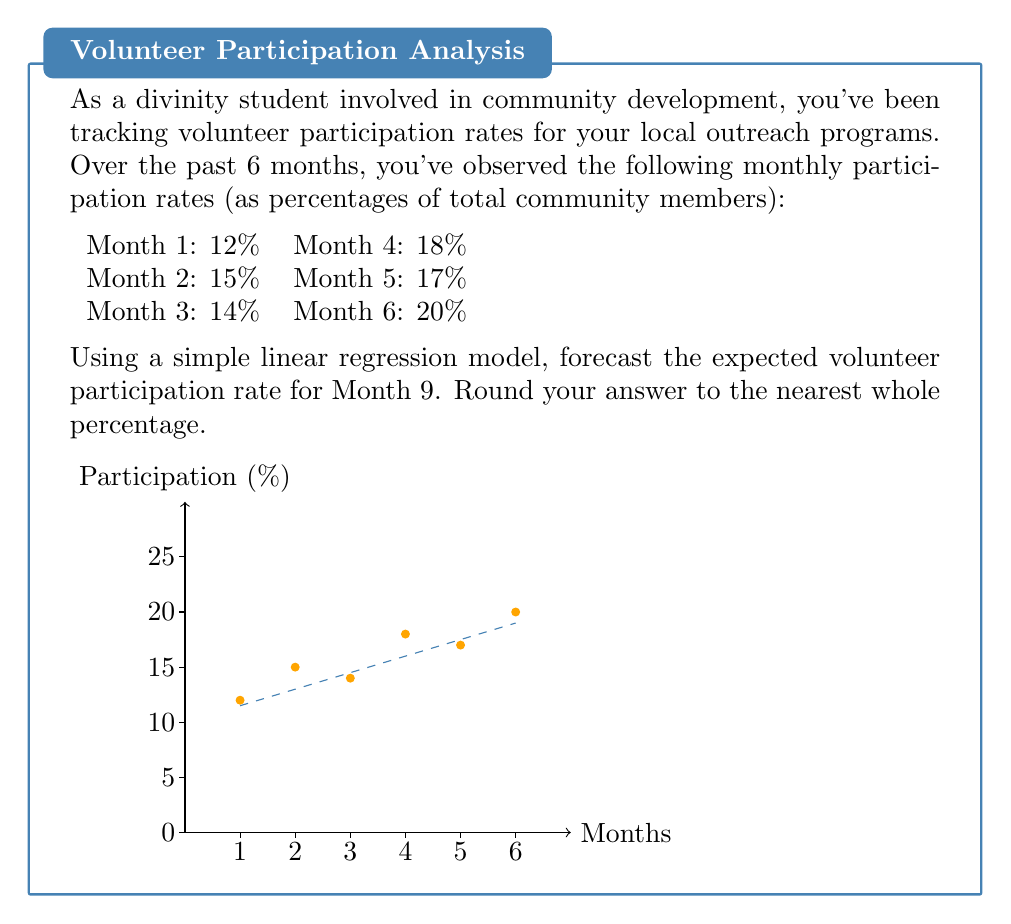Can you solve this math problem? To forecast the volunteer participation rate for Month 9 using simple linear regression, we'll follow these steps:

1) First, we need to calculate the slope (m) and y-intercept (b) of the regression line.

2) The formula for the slope is:
   $$m = \frac{n\sum xy - \sum x \sum y}{n\sum x^2 - (\sum x)^2}$$
   where n is the number of data points.

3) Let's calculate the necessary sums:
   $n = 6$
   $\sum x = 1 + 2 + 3 + 4 + 5 + 6 = 21$
   $\sum y = 12 + 15 + 14 + 18 + 17 + 20 = 96$
   $\sum xy = 1(12) + 2(15) + 3(14) + 4(18) + 5(17) + 6(20) = 371$
   $\sum x^2 = 1^2 + 2^2 + 3^2 + 4^2 + 5^2 + 6^2 = 91$

4) Now we can calculate the slope:
   $$m = \frac{6(371) - 21(96)}{6(91) - 21^2} = \frac{2226 - 2016}{546 - 441} = \frac{210}{105} = 2$$

5) To find the y-intercept, we use the formula:
   $$b = \bar{y} - m\bar{x}$$
   where $\bar{x}$ and $\bar{y}$ are the means of x and y respectively.

6) Calculate the means:
   $\bar{x} = 21/6 = 3.5$
   $\bar{y} = 96/6 = 16$

7) Now we can find b:
   $$b = 16 - 2(3.5) = 9$$

8) Our regression line equation is:
   $$y = 2x + 9$$

9) To forecast Month 9, we substitute x = 9:
   $$y = 2(9) + 9 = 27$$

10) Rounding to the nearest whole percentage, we get 27%.
Answer: 27% 